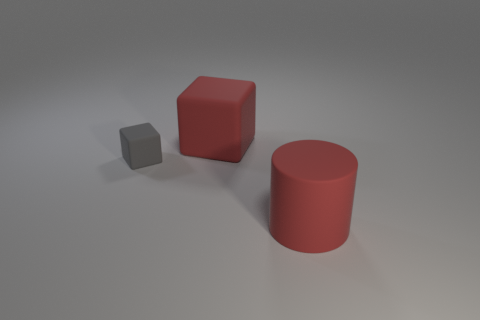Add 3 tiny matte objects. How many objects exist? 6 Subtract all cylinders. How many objects are left? 2 Subtract all large red metal things. Subtract all large red rubber objects. How many objects are left? 1 Add 2 tiny gray matte blocks. How many tiny gray matte blocks are left? 3 Add 1 big brown shiny cylinders. How many big brown shiny cylinders exist? 1 Subtract 0 gray balls. How many objects are left? 3 